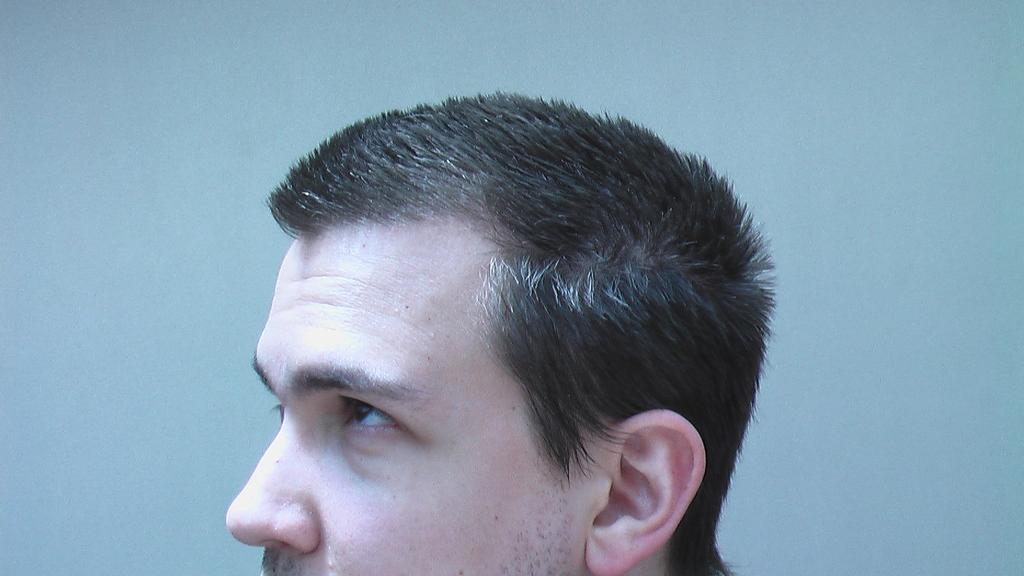Who is present in the image? There is a man in the image. What can be seen behind the man in the image? The background of the image is blue. What type of pen is the man holding in the image? There is no pen present in the image; only the man and the blue background are visible. 